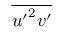Convert formula to latex. <formula><loc_0><loc_0><loc_500><loc_500>\overline { { { u ^ { \prime } } ^ { 2 } v ^ { \prime } } }</formula> 